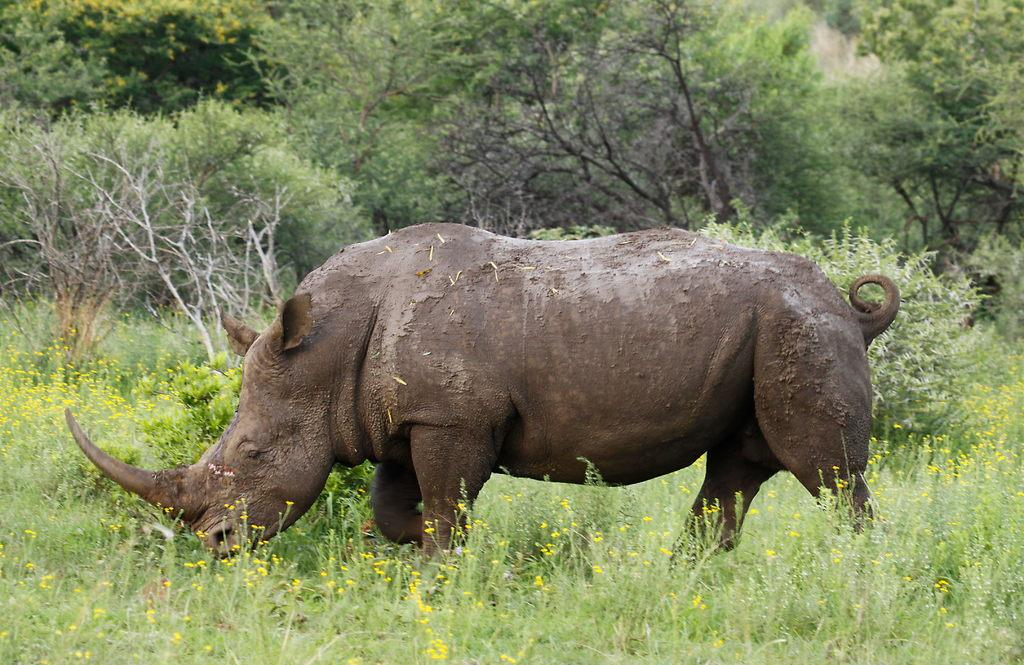What animal is the main subject of the picture? There is a rhinoceros in the picture. What is the rhinoceros doing in the picture? The rhinoceros is walking. What can be seen in the background of the picture? There are trees in the background of the picture. What type of sweater is the rhinoceros wearing in the picture? There is no sweater present in the image, as rhinoceroses do not wear clothing. 